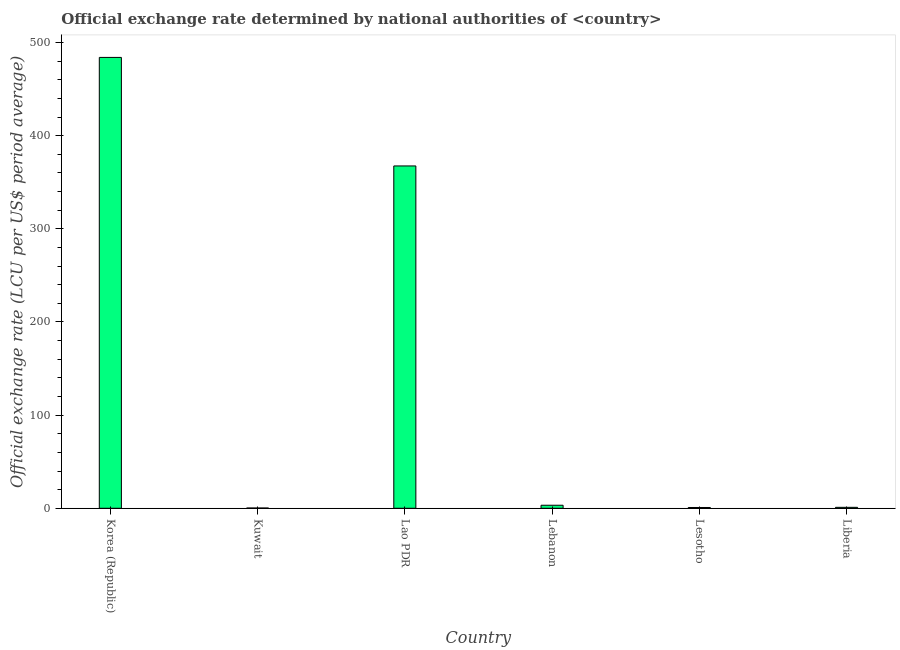Does the graph contain any zero values?
Make the answer very short. No. Does the graph contain grids?
Provide a succinct answer. No. What is the title of the graph?
Give a very brief answer. Official exchange rate determined by national authorities of <country>. What is the label or title of the Y-axis?
Your answer should be compact. Official exchange rate (LCU per US$ period average). What is the official exchange rate in Korea (Republic)?
Keep it short and to the point. 484. Across all countries, what is the maximum official exchange rate?
Make the answer very short. 484. Across all countries, what is the minimum official exchange rate?
Offer a terse response. 0.28. In which country was the official exchange rate maximum?
Provide a short and direct response. Korea (Republic). In which country was the official exchange rate minimum?
Provide a short and direct response. Kuwait. What is the sum of the official exchange rate?
Make the answer very short. 856.86. What is the difference between the official exchange rate in Korea (Republic) and Lesotho?
Offer a very short reply. 483.16. What is the average official exchange rate per country?
Make the answer very short. 142.81. What is the median official exchange rate?
Keep it short and to the point. 2.12. What is the ratio of the official exchange rate in Kuwait to that in Liberia?
Your response must be concise. 0.28. What is the difference between the highest and the second highest official exchange rate?
Offer a very short reply. 116.5. What is the difference between the highest and the lowest official exchange rate?
Keep it short and to the point. 483.72. How many bars are there?
Ensure brevity in your answer.  6. Are all the bars in the graph horizontal?
Offer a very short reply. No. Are the values on the major ticks of Y-axis written in scientific E-notation?
Make the answer very short. No. What is the Official exchange rate (LCU per US$ period average) in Korea (Republic)?
Your answer should be compact. 484. What is the Official exchange rate (LCU per US$ period average) of Kuwait?
Your response must be concise. 0.28. What is the Official exchange rate (LCU per US$ period average) in Lao PDR?
Provide a short and direct response. 367.5. What is the Official exchange rate (LCU per US$ period average) in Lebanon?
Your response must be concise. 3.24. What is the Official exchange rate (LCU per US$ period average) in Lesotho?
Provide a succinct answer. 0.84. What is the Official exchange rate (LCU per US$ period average) in Liberia?
Offer a very short reply. 1. What is the difference between the Official exchange rate (LCU per US$ period average) in Korea (Republic) and Kuwait?
Your answer should be compact. 483.72. What is the difference between the Official exchange rate (LCU per US$ period average) in Korea (Republic) and Lao PDR?
Ensure brevity in your answer.  116.5. What is the difference between the Official exchange rate (LCU per US$ period average) in Korea (Republic) and Lebanon?
Offer a very short reply. 480.76. What is the difference between the Official exchange rate (LCU per US$ period average) in Korea (Republic) and Lesotho?
Ensure brevity in your answer.  483.16. What is the difference between the Official exchange rate (LCU per US$ period average) in Korea (Republic) and Liberia?
Give a very brief answer. 483. What is the difference between the Official exchange rate (LCU per US$ period average) in Kuwait and Lao PDR?
Provide a succinct answer. -367.22. What is the difference between the Official exchange rate (LCU per US$ period average) in Kuwait and Lebanon?
Your answer should be compact. -2.97. What is the difference between the Official exchange rate (LCU per US$ period average) in Kuwait and Lesotho?
Give a very brief answer. -0.57. What is the difference between the Official exchange rate (LCU per US$ period average) in Kuwait and Liberia?
Provide a succinct answer. -0.72. What is the difference between the Official exchange rate (LCU per US$ period average) in Lao PDR and Lebanon?
Your response must be concise. 364.26. What is the difference between the Official exchange rate (LCU per US$ period average) in Lao PDR and Lesotho?
Provide a succinct answer. 366.66. What is the difference between the Official exchange rate (LCU per US$ period average) in Lao PDR and Liberia?
Make the answer very short. 366.5. What is the difference between the Official exchange rate (LCU per US$ period average) in Lebanon and Lesotho?
Make the answer very short. 2.4. What is the difference between the Official exchange rate (LCU per US$ period average) in Lebanon and Liberia?
Keep it short and to the point. 2.24. What is the difference between the Official exchange rate (LCU per US$ period average) in Lesotho and Liberia?
Ensure brevity in your answer.  -0.16. What is the ratio of the Official exchange rate (LCU per US$ period average) in Korea (Republic) to that in Kuwait?
Keep it short and to the point. 1751.3. What is the ratio of the Official exchange rate (LCU per US$ period average) in Korea (Republic) to that in Lao PDR?
Offer a terse response. 1.32. What is the ratio of the Official exchange rate (LCU per US$ period average) in Korea (Republic) to that in Lebanon?
Your answer should be compact. 149.26. What is the ratio of the Official exchange rate (LCU per US$ period average) in Korea (Republic) to that in Lesotho?
Give a very brief answer. 574.81. What is the ratio of the Official exchange rate (LCU per US$ period average) in Korea (Republic) to that in Liberia?
Keep it short and to the point. 484. What is the ratio of the Official exchange rate (LCU per US$ period average) in Kuwait to that in Lebanon?
Ensure brevity in your answer.  0.09. What is the ratio of the Official exchange rate (LCU per US$ period average) in Kuwait to that in Lesotho?
Keep it short and to the point. 0.33. What is the ratio of the Official exchange rate (LCU per US$ period average) in Kuwait to that in Liberia?
Provide a succinct answer. 0.28. What is the ratio of the Official exchange rate (LCU per US$ period average) in Lao PDR to that in Lebanon?
Give a very brief answer. 113.33. What is the ratio of the Official exchange rate (LCU per US$ period average) in Lao PDR to that in Lesotho?
Offer a very short reply. 436.45. What is the ratio of the Official exchange rate (LCU per US$ period average) in Lao PDR to that in Liberia?
Give a very brief answer. 367.5. What is the ratio of the Official exchange rate (LCU per US$ period average) in Lebanon to that in Lesotho?
Your response must be concise. 3.85. What is the ratio of the Official exchange rate (LCU per US$ period average) in Lebanon to that in Liberia?
Provide a succinct answer. 3.24. What is the ratio of the Official exchange rate (LCU per US$ period average) in Lesotho to that in Liberia?
Your answer should be compact. 0.84. 